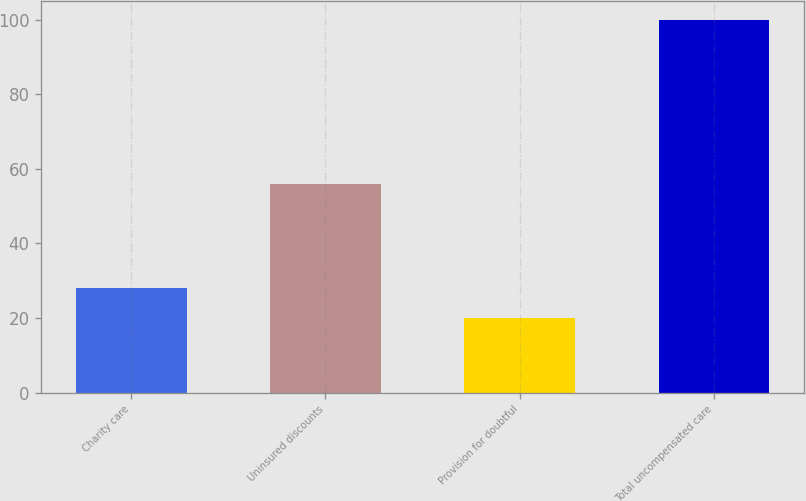Convert chart to OTSL. <chart><loc_0><loc_0><loc_500><loc_500><bar_chart><fcel>Charity care<fcel>Uninsured discounts<fcel>Provision for doubtful<fcel>Total uncompensated care<nl><fcel>28<fcel>56<fcel>20<fcel>100<nl></chart> 